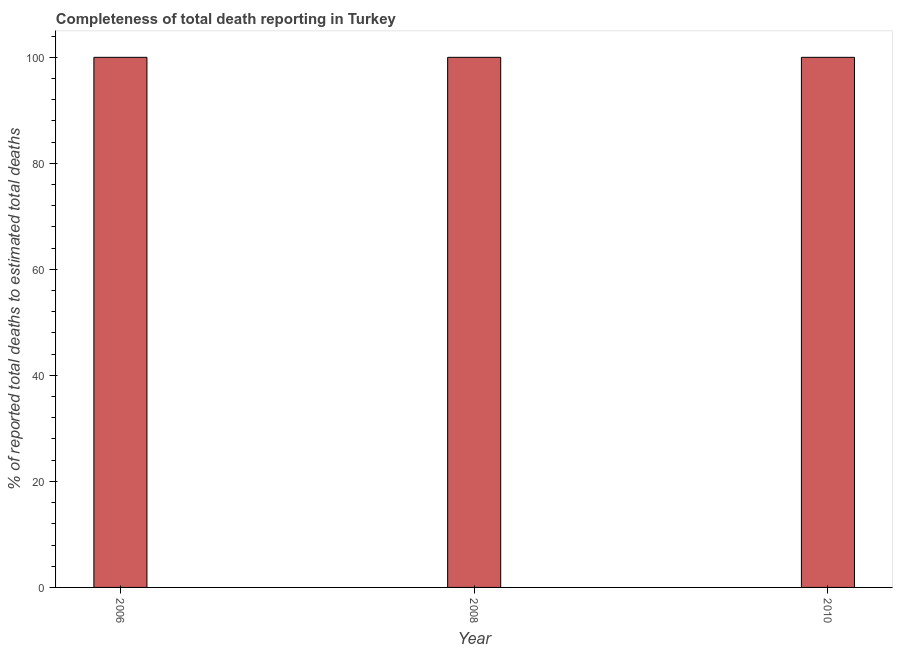Does the graph contain any zero values?
Your answer should be compact. No. Does the graph contain grids?
Ensure brevity in your answer.  No. What is the title of the graph?
Make the answer very short. Completeness of total death reporting in Turkey. What is the label or title of the X-axis?
Your answer should be compact. Year. What is the label or title of the Y-axis?
Give a very brief answer. % of reported total deaths to estimated total deaths. What is the completeness of total death reports in 2006?
Your answer should be compact. 100. Across all years, what is the maximum completeness of total death reports?
Keep it short and to the point. 100. In which year was the completeness of total death reports minimum?
Give a very brief answer. 2006. What is the sum of the completeness of total death reports?
Offer a very short reply. 300. What is the difference between the completeness of total death reports in 2008 and 2010?
Provide a short and direct response. 0. Is the completeness of total death reports in 2008 less than that in 2010?
Offer a very short reply. No. What is the difference between the highest and the second highest completeness of total death reports?
Ensure brevity in your answer.  0. How many bars are there?
Your response must be concise. 3. How many years are there in the graph?
Your answer should be very brief. 3. What is the % of reported total deaths to estimated total deaths of 2008?
Your response must be concise. 100. What is the % of reported total deaths to estimated total deaths of 2010?
Make the answer very short. 100. What is the difference between the % of reported total deaths to estimated total deaths in 2006 and 2010?
Give a very brief answer. 0. What is the difference between the % of reported total deaths to estimated total deaths in 2008 and 2010?
Provide a succinct answer. 0. What is the ratio of the % of reported total deaths to estimated total deaths in 2006 to that in 2010?
Offer a terse response. 1. What is the ratio of the % of reported total deaths to estimated total deaths in 2008 to that in 2010?
Offer a terse response. 1. 